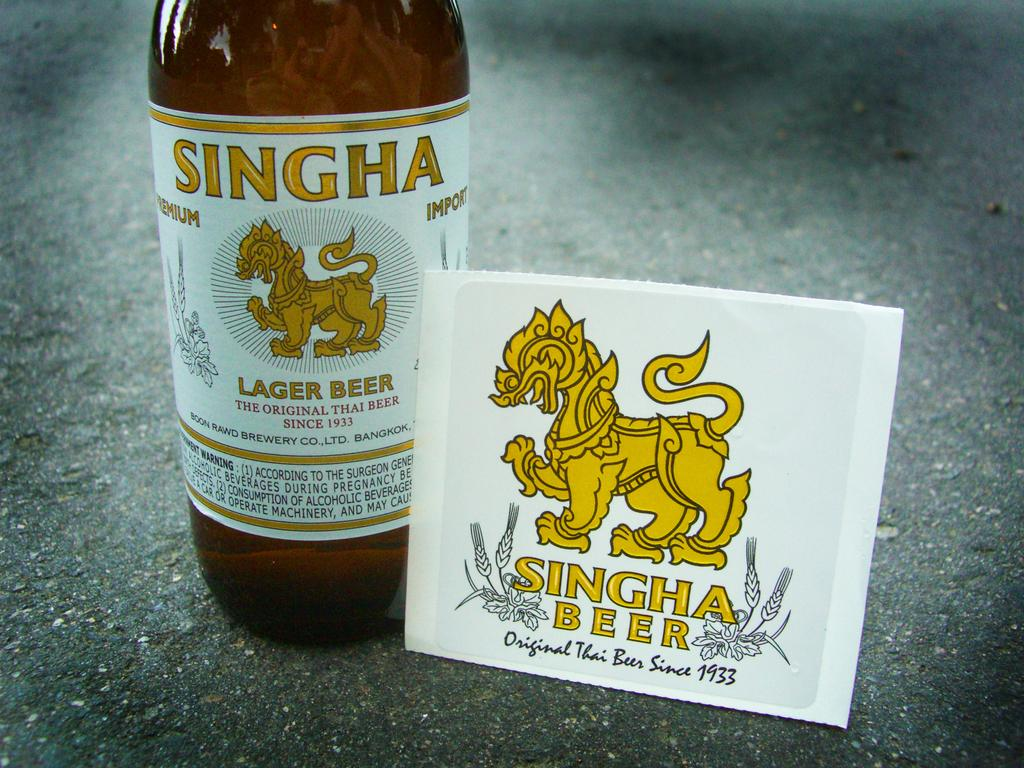<image>
Share a concise interpretation of the image provided. Singha Beer is a lager brewed in Thailand since 1933. 